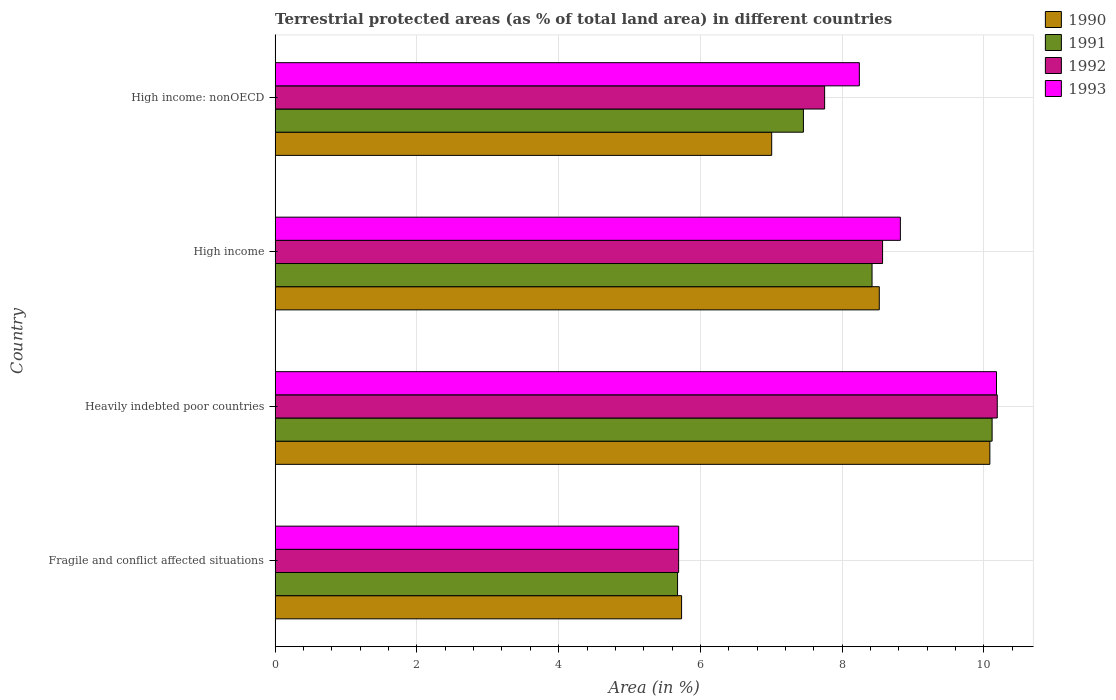How many groups of bars are there?
Your answer should be compact. 4. Are the number of bars per tick equal to the number of legend labels?
Keep it short and to the point. Yes. Are the number of bars on each tick of the Y-axis equal?
Your answer should be compact. Yes. What is the label of the 3rd group of bars from the top?
Make the answer very short. Heavily indebted poor countries. What is the percentage of terrestrial protected land in 1993 in High income?
Your response must be concise. 8.82. Across all countries, what is the maximum percentage of terrestrial protected land in 1993?
Offer a terse response. 10.18. Across all countries, what is the minimum percentage of terrestrial protected land in 1991?
Your answer should be very brief. 5.68. In which country was the percentage of terrestrial protected land in 1990 maximum?
Offer a terse response. Heavily indebted poor countries. In which country was the percentage of terrestrial protected land in 1993 minimum?
Make the answer very short. Fragile and conflict affected situations. What is the total percentage of terrestrial protected land in 1991 in the graph?
Keep it short and to the point. 31.67. What is the difference between the percentage of terrestrial protected land in 1993 in Fragile and conflict affected situations and that in High income: nonOECD?
Ensure brevity in your answer.  -2.55. What is the difference between the percentage of terrestrial protected land in 1993 in Heavily indebted poor countries and the percentage of terrestrial protected land in 1992 in High income: nonOECD?
Offer a very short reply. 2.42. What is the average percentage of terrestrial protected land in 1991 per country?
Ensure brevity in your answer.  7.92. What is the difference between the percentage of terrestrial protected land in 1991 and percentage of terrestrial protected land in 1992 in Fragile and conflict affected situations?
Provide a short and direct response. -0.01. What is the ratio of the percentage of terrestrial protected land in 1991 in Fragile and conflict affected situations to that in High income: nonOECD?
Offer a terse response. 0.76. Is the difference between the percentage of terrestrial protected land in 1991 in Fragile and conflict affected situations and High income greater than the difference between the percentage of terrestrial protected land in 1992 in Fragile and conflict affected situations and High income?
Offer a terse response. Yes. What is the difference between the highest and the second highest percentage of terrestrial protected land in 1990?
Give a very brief answer. 1.56. What is the difference between the highest and the lowest percentage of terrestrial protected land in 1993?
Provide a short and direct response. 4.48. Is it the case that in every country, the sum of the percentage of terrestrial protected land in 1991 and percentage of terrestrial protected land in 1992 is greater than the percentage of terrestrial protected land in 1993?
Your answer should be very brief. Yes. How many bars are there?
Offer a very short reply. 16. Are all the bars in the graph horizontal?
Your answer should be very brief. Yes. How many countries are there in the graph?
Your response must be concise. 4. Does the graph contain any zero values?
Your response must be concise. No. Does the graph contain grids?
Your answer should be compact. Yes. Where does the legend appear in the graph?
Keep it short and to the point. Top right. How are the legend labels stacked?
Offer a very short reply. Vertical. What is the title of the graph?
Your answer should be compact. Terrestrial protected areas (as % of total land area) in different countries. Does "1996" appear as one of the legend labels in the graph?
Offer a very short reply. No. What is the label or title of the X-axis?
Offer a terse response. Area (in %). What is the Area (in %) in 1990 in Fragile and conflict affected situations?
Provide a short and direct response. 5.73. What is the Area (in %) in 1991 in Fragile and conflict affected situations?
Give a very brief answer. 5.68. What is the Area (in %) in 1992 in Fragile and conflict affected situations?
Ensure brevity in your answer.  5.69. What is the Area (in %) in 1993 in Fragile and conflict affected situations?
Your response must be concise. 5.69. What is the Area (in %) of 1990 in Heavily indebted poor countries?
Make the answer very short. 10.08. What is the Area (in %) of 1991 in Heavily indebted poor countries?
Offer a very short reply. 10.11. What is the Area (in %) in 1992 in Heavily indebted poor countries?
Provide a short and direct response. 10.19. What is the Area (in %) in 1993 in Heavily indebted poor countries?
Give a very brief answer. 10.18. What is the Area (in %) in 1990 in High income?
Provide a succinct answer. 8.52. What is the Area (in %) in 1991 in High income?
Offer a very short reply. 8.42. What is the Area (in %) in 1992 in High income?
Provide a short and direct response. 8.57. What is the Area (in %) in 1993 in High income?
Ensure brevity in your answer.  8.82. What is the Area (in %) of 1990 in High income: nonOECD?
Your answer should be compact. 7.01. What is the Area (in %) of 1991 in High income: nonOECD?
Make the answer very short. 7.45. What is the Area (in %) of 1992 in High income: nonOECD?
Keep it short and to the point. 7.75. What is the Area (in %) of 1993 in High income: nonOECD?
Make the answer very short. 8.24. Across all countries, what is the maximum Area (in %) of 1990?
Your answer should be very brief. 10.08. Across all countries, what is the maximum Area (in %) of 1991?
Give a very brief answer. 10.11. Across all countries, what is the maximum Area (in %) in 1992?
Your response must be concise. 10.19. Across all countries, what is the maximum Area (in %) in 1993?
Give a very brief answer. 10.18. Across all countries, what is the minimum Area (in %) of 1990?
Keep it short and to the point. 5.73. Across all countries, what is the minimum Area (in %) in 1991?
Ensure brevity in your answer.  5.68. Across all countries, what is the minimum Area (in %) of 1992?
Your answer should be compact. 5.69. Across all countries, what is the minimum Area (in %) in 1993?
Keep it short and to the point. 5.69. What is the total Area (in %) in 1990 in the graph?
Provide a succinct answer. 31.35. What is the total Area (in %) in 1991 in the graph?
Give a very brief answer. 31.67. What is the total Area (in %) in 1992 in the graph?
Make the answer very short. 32.2. What is the total Area (in %) in 1993 in the graph?
Your response must be concise. 32.93. What is the difference between the Area (in %) of 1990 in Fragile and conflict affected situations and that in Heavily indebted poor countries?
Your answer should be compact. -4.35. What is the difference between the Area (in %) of 1991 in Fragile and conflict affected situations and that in Heavily indebted poor countries?
Your answer should be compact. -4.44. What is the difference between the Area (in %) of 1992 in Fragile and conflict affected situations and that in Heavily indebted poor countries?
Offer a terse response. -4.49. What is the difference between the Area (in %) of 1993 in Fragile and conflict affected situations and that in Heavily indebted poor countries?
Your answer should be compact. -4.48. What is the difference between the Area (in %) of 1990 in Fragile and conflict affected situations and that in High income?
Give a very brief answer. -2.79. What is the difference between the Area (in %) in 1991 in Fragile and conflict affected situations and that in High income?
Provide a succinct answer. -2.74. What is the difference between the Area (in %) of 1992 in Fragile and conflict affected situations and that in High income?
Offer a very short reply. -2.88. What is the difference between the Area (in %) in 1993 in Fragile and conflict affected situations and that in High income?
Your answer should be very brief. -3.13. What is the difference between the Area (in %) of 1990 in Fragile and conflict affected situations and that in High income: nonOECD?
Provide a short and direct response. -1.27. What is the difference between the Area (in %) in 1991 in Fragile and conflict affected situations and that in High income: nonOECD?
Make the answer very short. -1.78. What is the difference between the Area (in %) of 1992 in Fragile and conflict affected situations and that in High income: nonOECD?
Make the answer very short. -2.06. What is the difference between the Area (in %) of 1993 in Fragile and conflict affected situations and that in High income: nonOECD?
Provide a succinct answer. -2.55. What is the difference between the Area (in %) of 1990 in Heavily indebted poor countries and that in High income?
Provide a short and direct response. 1.56. What is the difference between the Area (in %) of 1991 in Heavily indebted poor countries and that in High income?
Your answer should be compact. 1.69. What is the difference between the Area (in %) of 1992 in Heavily indebted poor countries and that in High income?
Your response must be concise. 1.62. What is the difference between the Area (in %) in 1993 in Heavily indebted poor countries and that in High income?
Provide a succinct answer. 1.36. What is the difference between the Area (in %) in 1990 in Heavily indebted poor countries and that in High income: nonOECD?
Offer a terse response. 3.08. What is the difference between the Area (in %) in 1991 in Heavily indebted poor countries and that in High income: nonOECD?
Provide a succinct answer. 2.66. What is the difference between the Area (in %) in 1992 in Heavily indebted poor countries and that in High income: nonOECD?
Provide a succinct answer. 2.44. What is the difference between the Area (in %) in 1993 in Heavily indebted poor countries and that in High income: nonOECD?
Keep it short and to the point. 1.93. What is the difference between the Area (in %) of 1990 in High income and that in High income: nonOECD?
Provide a short and direct response. 1.52. What is the difference between the Area (in %) in 1991 in High income and that in High income: nonOECD?
Make the answer very short. 0.97. What is the difference between the Area (in %) in 1992 in High income and that in High income: nonOECD?
Your answer should be very brief. 0.82. What is the difference between the Area (in %) of 1993 in High income and that in High income: nonOECD?
Keep it short and to the point. 0.58. What is the difference between the Area (in %) of 1990 in Fragile and conflict affected situations and the Area (in %) of 1991 in Heavily indebted poor countries?
Give a very brief answer. -4.38. What is the difference between the Area (in %) in 1990 in Fragile and conflict affected situations and the Area (in %) in 1992 in Heavily indebted poor countries?
Offer a terse response. -4.45. What is the difference between the Area (in %) of 1990 in Fragile and conflict affected situations and the Area (in %) of 1993 in Heavily indebted poor countries?
Your answer should be compact. -4.44. What is the difference between the Area (in %) of 1991 in Fragile and conflict affected situations and the Area (in %) of 1992 in Heavily indebted poor countries?
Provide a succinct answer. -4.51. What is the difference between the Area (in %) of 1991 in Fragile and conflict affected situations and the Area (in %) of 1993 in Heavily indebted poor countries?
Make the answer very short. -4.5. What is the difference between the Area (in %) in 1992 in Fragile and conflict affected situations and the Area (in %) in 1993 in Heavily indebted poor countries?
Offer a very short reply. -4.48. What is the difference between the Area (in %) in 1990 in Fragile and conflict affected situations and the Area (in %) in 1991 in High income?
Ensure brevity in your answer.  -2.69. What is the difference between the Area (in %) in 1990 in Fragile and conflict affected situations and the Area (in %) in 1992 in High income?
Your response must be concise. -2.84. What is the difference between the Area (in %) in 1990 in Fragile and conflict affected situations and the Area (in %) in 1993 in High income?
Offer a terse response. -3.09. What is the difference between the Area (in %) of 1991 in Fragile and conflict affected situations and the Area (in %) of 1992 in High income?
Make the answer very short. -2.89. What is the difference between the Area (in %) of 1991 in Fragile and conflict affected situations and the Area (in %) of 1993 in High income?
Offer a terse response. -3.14. What is the difference between the Area (in %) of 1992 in Fragile and conflict affected situations and the Area (in %) of 1993 in High income?
Your response must be concise. -3.13. What is the difference between the Area (in %) of 1990 in Fragile and conflict affected situations and the Area (in %) of 1991 in High income: nonOECD?
Your answer should be very brief. -1.72. What is the difference between the Area (in %) of 1990 in Fragile and conflict affected situations and the Area (in %) of 1992 in High income: nonOECD?
Keep it short and to the point. -2.02. What is the difference between the Area (in %) of 1990 in Fragile and conflict affected situations and the Area (in %) of 1993 in High income: nonOECD?
Ensure brevity in your answer.  -2.51. What is the difference between the Area (in %) in 1991 in Fragile and conflict affected situations and the Area (in %) in 1992 in High income: nonOECD?
Provide a succinct answer. -2.07. What is the difference between the Area (in %) in 1991 in Fragile and conflict affected situations and the Area (in %) in 1993 in High income: nonOECD?
Make the answer very short. -2.56. What is the difference between the Area (in %) of 1992 in Fragile and conflict affected situations and the Area (in %) of 1993 in High income: nonOECD?
Make the answer very short. -2.55. What is the difference between the Area (in %) in 1990 in Heavily indebted poor countries and the Area (in %) in 1991 in High income?
Ensure brevity in your answer.  1.66. What is the difference between the Area (in %) of 1990 in Heavily indebted poor countries and the Area (in %) of 1992 in High income?
Provide a short and direct response. 1.51. What is the difference between the Area (in %) of 1990 in Heavily indebted poor countries and the Area (in %) of 1993 in High income?
Offer a terse response. 1.26. What is the difference between the Area (in %) of 1991 in Heavily indebted poor countries and the Area (in %) of 1992 in High income?
Give a very brief answer. 1.55. What is the difference between the Area (in %) in 1991 in Heavily indebted poor countries and the Area (in %) in 1993 in High income?
Your response must be concise. 1.29. What is the difference between the Area (in %) in 1992 in Heavily indebted poor countries and the Area (in %) in 1993 in High income?
Your answer should be very brief. 1.37. What is the difference between the Area (in %) in 1990 in Heavily indebted poor countries and the Area (in %) in 1991 in High income: nonOECD?
Give a very brief answer. 2.63. What is the difference between the Area (in %) of 1990 in Heavily indebted poor countries and the Area (in %) of 1992 in High income: nonOECD?
Ensure brevity in your answer.  2.33. What is the difference between the Area (in %) in 1990 in Heavily indebted poor countries and the Area (in %) in 1993 in High income: nonOECD?
Make the answer very short. 1.84. What is the difference between the Area (in %) of 1991 in Heavily indebted poor countries and the Area (in %) of 1992 in High income: nonOECD?
Your answer should be very brief. 2.36. What is the difference between the Area (in %) of 1991 in Heavily indebted poor countries and the Area (in %) of 1993 in High income: nonOECD?
Your answer should be compact. 1.87. What is the difference between the Area (in %) of 1992 in Heavily indebted poor countries and the Area (in %) of 1993 in High income: nonOECD?
Provide a short and direct response. 1.95. What is the difference between the Area (in %) of 1990 in High income and the Area (in %) of 1991 in High income: nonOECD?
Give a very brief answer. 1.07. What is the difference between the Area (in %) in 1990 in High income and the Area (in %) in 1992 in High income: nonOECD?
Offer a terse response. 0.77. What is the difference between the Area (in %) in 1990 in High income and the Area (in %) in 1993 in High income: nonOECD?
Make the answer very short. 0.28. What is the difference between the Area (in %) of 1991 in High income and the Area (in %) of 1992 in High income: nonOECD?
Your answer should be compact. 0.67. What is the difference between the Area (in %) in 1991 in High income and the Area (in %) in 1993 in High income: nonOECD?
Keep it short and to the point. 0.18. What is the difference between the Area (in %) of 1992 in High income and the Area (in %) of 1993 in High income: nonOECD?
Your answer should be compact. 0.33. What is the average Area (in %) of 1990 per country?
Offer a very short reply. 7.84. What is the average Area (in %) in 1991 per country?
Your response must be concise. 7.92. What is the average Area (in %) of 1992 per country?
Offer a terse response. 8.05. What is the average Area (in %) of 1993 per country?
Give a very brief answer. 8.23. What is the difference between the Area (in %) in 1990 and Area (in %) in 1991 in Fragile and conflict affected situations?
Offer a very short reply. 0.06. What is the difference between the Area (in %) of 1990 and Area (in %) of 1992 in Fragile and conflict affected situations?
Ensure brevity in your answer.  0.04. What is the difference between the Area (in %) of 1990 and Area (in %) of 1993 in Fragile and conflict affected situations?
Your answer should be compact. 0.04. What is the difference between the Area (in %) in 1991 and Area (in %) in 1992 in Fragile and conflict affected situations?
Offer a very short reply. -0.01. What is the difference between the Area (in %) of 1991 and Area (in %) of 1993 in Fragile and conflict affected situations?
Your answer should be compact. -0.02. What is the difference between the Area (in %) of 1992 and Area (in %) of 1993 in Fragile and conflict affected situations?
Your answer should be compact. -0. What is the difference between the Area (in %) of 1990 and Area (in %) of 1991 in Heavily indebted poor countries?
Ensure brevity in your answer.  -0.03. What is the difference between the Area (in %) of 1990 and Area (in %) of 1992 in Heavily indebted poor countries?
Offer a terse response. -0.1. What is the difference between the Area (in %) of 1990 and Area (in %) of 1993 in Heavily indebted poor countries?
Offer a very short reply. -0.09. What is the difference between the Area (in %) in 1991 and Area (in %) in 1992 in Heavily indebted poor countries?
Offer a very short reply. -0.07. What is the difference between the Area (in %) in 1991 and Area (in %) in 1993 in Heavily indebted poor countries?
Provide a succinct answer. -0.06. What is the difference between the Area (in %) of 1992 and Area (in %) of 1993 in Heavily indebted poor countries?
Provide a succinct answer. 0.01. What is the difference between the Area (in %) in 1990 and Area (in %) in 1991 in High income?
Your answer should be compact. 0.1. What is the difference between the Area (in %) in 1990 and Area (in %) in 1992 in High income?
Ensure brevity in your answer.  -0.05. What is the difference between the Area (in %) in 1990 and Area (in %) in 1993 in High income?
Your answer should be compact. -0.3. What is the difference between the Area (in %) of 1991 and Area (in %) of 1992 in High income?
Make the answer very short. -0.15. What is the difference between the Area (in %) of 1991 and Area (in %) of 1993 in High income?
Keep it short and to the point. -0.4. What is the difference between the Area (in %) in 1992 and Area (in %) in 1993 in High income?
Offer a very short reply. -0.25. What is the difference between the Area (in %) in 1990 and Area (in %) in 1991 in High income: nonOECD?
Keep it short and to the point. -0.45. What is the difference between the Area (in %) in 1990 and Area (in %) in 1992 in High income: nonOECD?
Keep it short and to the point. -0.75. What is the difference between the Area (in %) in 1990 and Area (in %) in 1993 in High income: nonOECD?
Make the answer very short. -1.24. What is the difference between the Area (in %) in 1991 and Area (in %) in 1992 in High income: nonOECD?
Offer a very short reply. -0.3. What is the difference between the Area (in %) of 1991 and Area (in %) of 1993 in High income: nonOECD?
Provide a succinct answer. -0.79. What is the difference between the Area (in %) in 1992 and Area (in %) in 1993 in High income: nonOECD?
Give a very brief answer. -0.49. What is the ratio of the Area (in %) in 1990 in Fragile and conflict affected situations to that in Heavily indebted poor countries?
Your answer should be compact. 0.57. What is the ratio of the Area (in %) in 1991 in Fragile and conflict affected situations to that in Heavily indebted poor countries?
Provide a short and direct response. 0.56. What is the ratio of the Area (in %) of 1992 in Fragile and conflict affected situations to that in Heavily indebted poor countries?
Keep it short and to the point. 0.56. What is the ratio of the Area (in %) of 1993 in Fragile and conflict affected situations to that in Heavily indebted poor countries?
Keep it short and to the point. 0.56. What is the ratio of the Area (in %) in 1990 in Fragile and conflict affected situations to that in High income?
Give a very brief answer. 0.67. What is the ratio of the Area (in %) of 1991 in Fragile and conflict affected situations to that in High income?
Offer a very short reply. 0.67. What is the ratio of the Area (in %) of 1992 in Fragile and conflict affected situations to that in High income?
Your answer should be compact. 0.66. What is the ratio of the Area (in %) of 1993 in Fragile and conflict affected situations to that in High income?
Offer a terse response. 0.65. What is the ratio of the Area (in %) in 1990 in Fragile and conflict affected situations to that in High income: nonOECD?
Your answer should be compact. 0.82. What is the ratio of the Area (in %) in 1991 in Fragile and conflict affected situations to that in High income: nonOECD?
Ensure brevity in your answer.  0.76. What is the ratio of the Area (in %) of 1992 in Fragile and conflict affected situations to that in High income: nonOECD?
Your answer should be very brief. 0.73. What is the ratio of the Area (in %) in 1993 in Fragile and conflict affected situations to that in High income: nonOECD?
Your answer should be very brief. 0.69. What is the ratio of the Area (in %) in 1990 in Heavily indebted poor countries to that in High income?
Your answer should be compact. 1.18. What is the ratio of the Area (in %) of 1991 in Heavily indebted poor countries to that in High income?
Provide a succinct answer. 1.2. What is the ratio of the Area (in %) of 1992 in Heavily indebted poor countries to that in High income?
Keep it short and to the point. 1.19. What is the ratio of the Area (in %) in 1993 in Heavily indebted poor countries to that in High income?
Ensure brevity in your answer.  1.15. What is the ratio of the Area (in %) in 1990 in Heavily indebted poor countries to that in High income: nonOECD?
Your response must be concise. 1.44. What is the ratio of the Area (in %) in 1991 in Heavily indebted poor countries to that in High income: nonOECD?
Keep it short and to the point. 1.36. What is the ratio of the Area (in %) of 1992 in Heavily indebted poor countries to that in High income: nonOECD?
Give a very brief answer. 1.31. What is the ratio of the Area (in %) in 1993 in Heavily indebted poor countries to that in High income: nonOECD?
Your answer should be very brief. 1.23. What is the ratio of the Area (in %) in 1990 in High income to that in High income: nonOECD?
Provide a short and direct response. 1.22. What is the ratio of the Area (in %) of 1991 in High income to that in High income: nonOECD?
Offer a terse response. 1.13. What is the ratio of the Area (in %) in 1992 in High income to that in High income: nonOECD?
Provide a short and direct response. 1.11. What is the ratio of the Area (in %) of 1993 in High income to that in High income: nonOECD?
Provide a succinct answer. 1.07. What is the difference between the highest and the second highest Area (in %) of 1990?
Your response must be concise. 1.56. What is the difference between the highest and the second highest Area (in %) of 1991?
Make the answer very short. 1.69. What is the difference between the highest and the second highest Area (in %) of 1992?
Your answer should be very brief. 1.62. What is the difference between the highest and the second highest Area (in %) in 1993?
Provide a short and direct response. 1.36. What is the difference between the highest and the lowest Area (in %) in 1990?
Keep it short and to the point. 4.35. What is the difference between the highest and the lowest Area (in %) in 1991?
Your response must be concise. 4.44. What is the difference between the highest and the lowest Area (in %) of 1992?
Offer a very short reply. 4.49. What is the difference between the highest and the lowest Area (in %) in 1993?
Give a very brief answer. 4.48. 